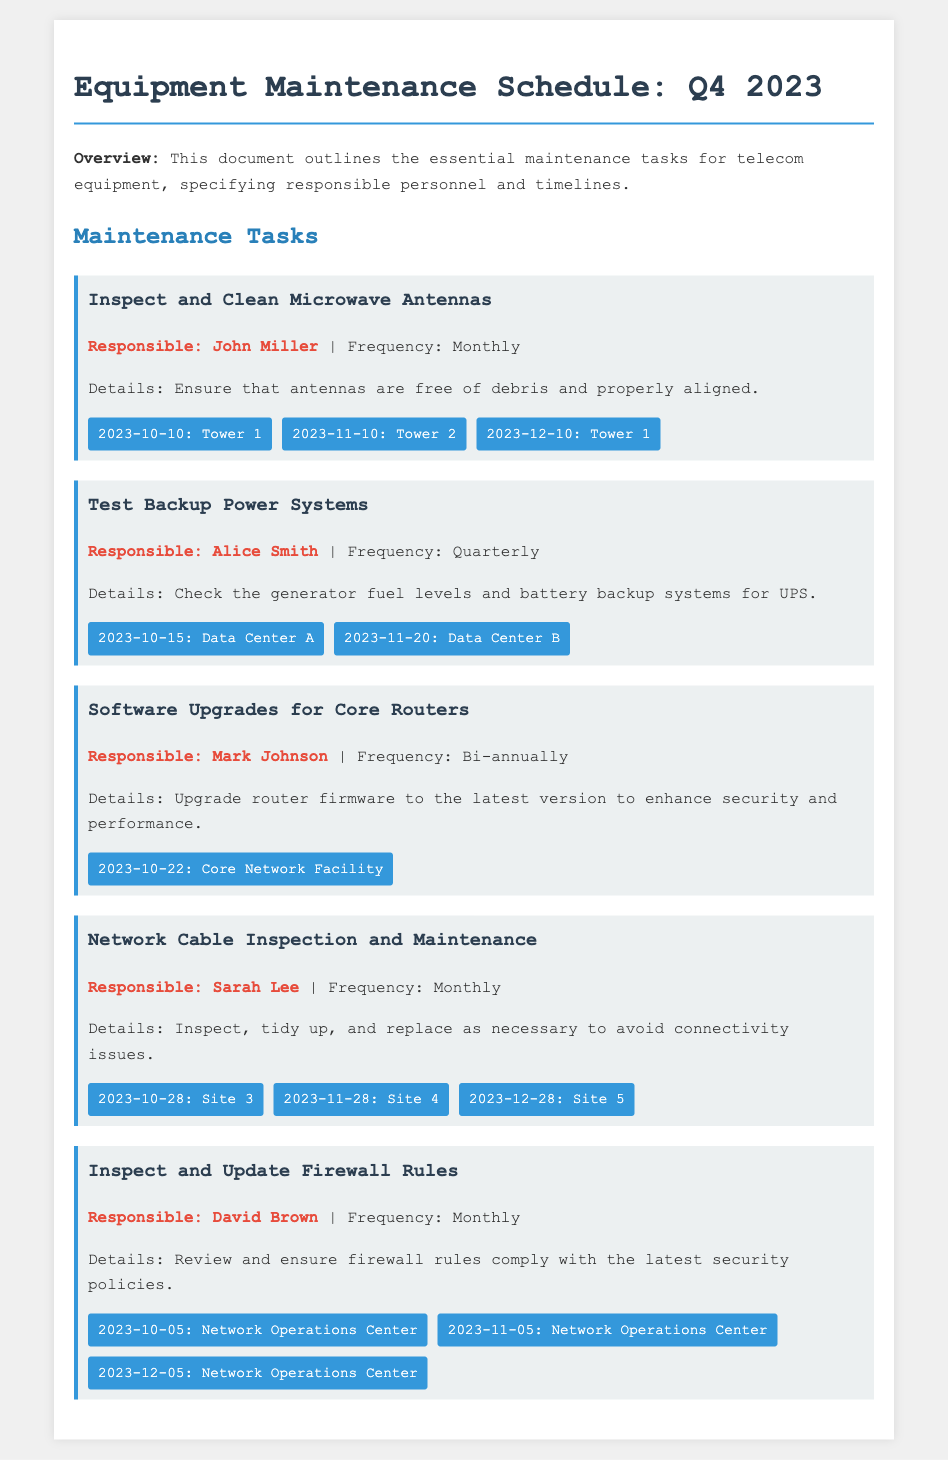What is the first scheduled task for the quarter? The first task mentioned in the schedule is "Inspect and Clean Microwave Antennas."
Answer: Inspect and Clean Microwave Antennas Who is responsible for inspecting the network cable? The document clearly states that Sarah Lee is the responsible person for inspecting network cables.
Answer: Sarah Lee When is the software upgrade for core routers scheduled? The document provides the specific date for the core routers' software upgrade as October 22, 2023.
Answer: 2023-10-22 How often is the backup power systems test conducted? The text indicates that testing of the backup power systems is done quarterly.
Answer: Quarterly Which site has a network cable inspection scheduled for December? The schedule indicates that Site 5 has a network cable inspection on December 28, 2023.
Answer: Site 5 How many tasks are scheduled for October? The document lists five maintenance tasks, with specific dates in October for each.
Answer: Five 